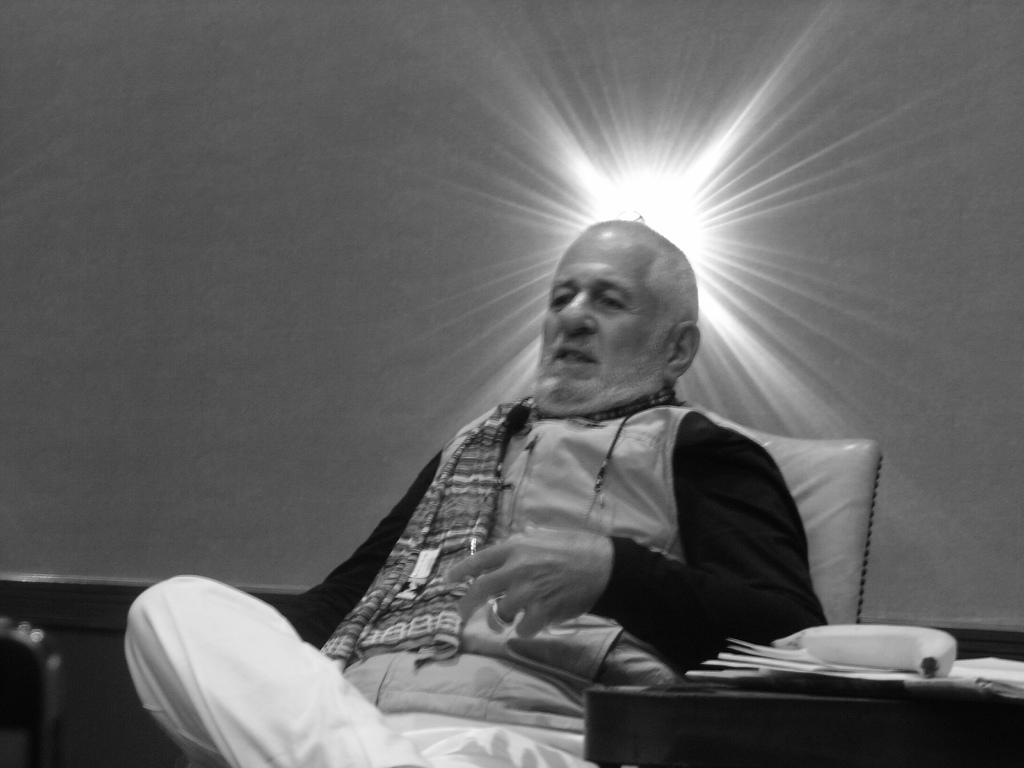What is the person in the image doing? The person is sitting in the image. What is the person wearing? The person is wearing clothes. What type of fruit can be seen in the image? There is a banana visible in the image. What type of objects are present in the image? There are papers in the image. What can be seen in the background of the image? There is a wall in the image. What type of kite is the person flying in the image? There is no kite present in the image. What type of maid is attending to the person in the image? There is no maid present in the image. 